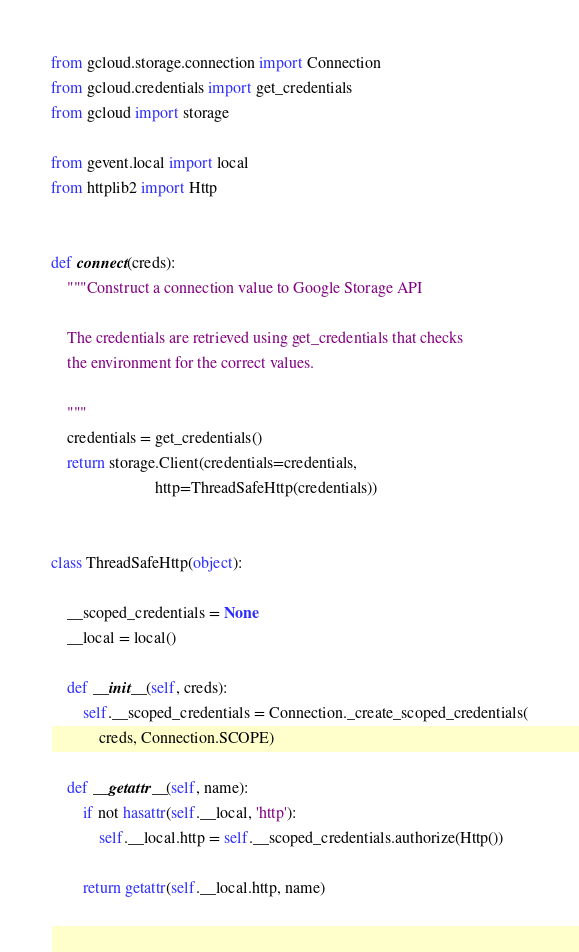<code> <loc_0><loc_0><loc_500><loc_500><_Python_>from gcloud.storage.connection import Connection
from gcloud.credentials import get_credentials
from gcloud import storage

from gevent.local import local
from httplib2 import Http


def connect(creds):
    """Construct a connection value to Google Storage API

    The credentials are retrieved using get_credentials that checks
    the environment for the correct values.

    """
    credentials = get_credentials()
    return storage.Client(credentials=credentials,
                          http=ThreadSafeHttp(credentials))


class ThreadSafeHttp(object):

    __scoped_credentials = None
    __local = local()

    def __init__(self, creds):
        self.__scoped_credentials = Connection._create_scoped_credentials(
            creds, Connection.SCOPE)

    def __getattr__(self, name):
        if not hasattr(self.__local, 'http'):
            self.__local.http = self.__scoped_credentials.authorize(Http())

        return getattr(self.__local.http, name)
</code> 